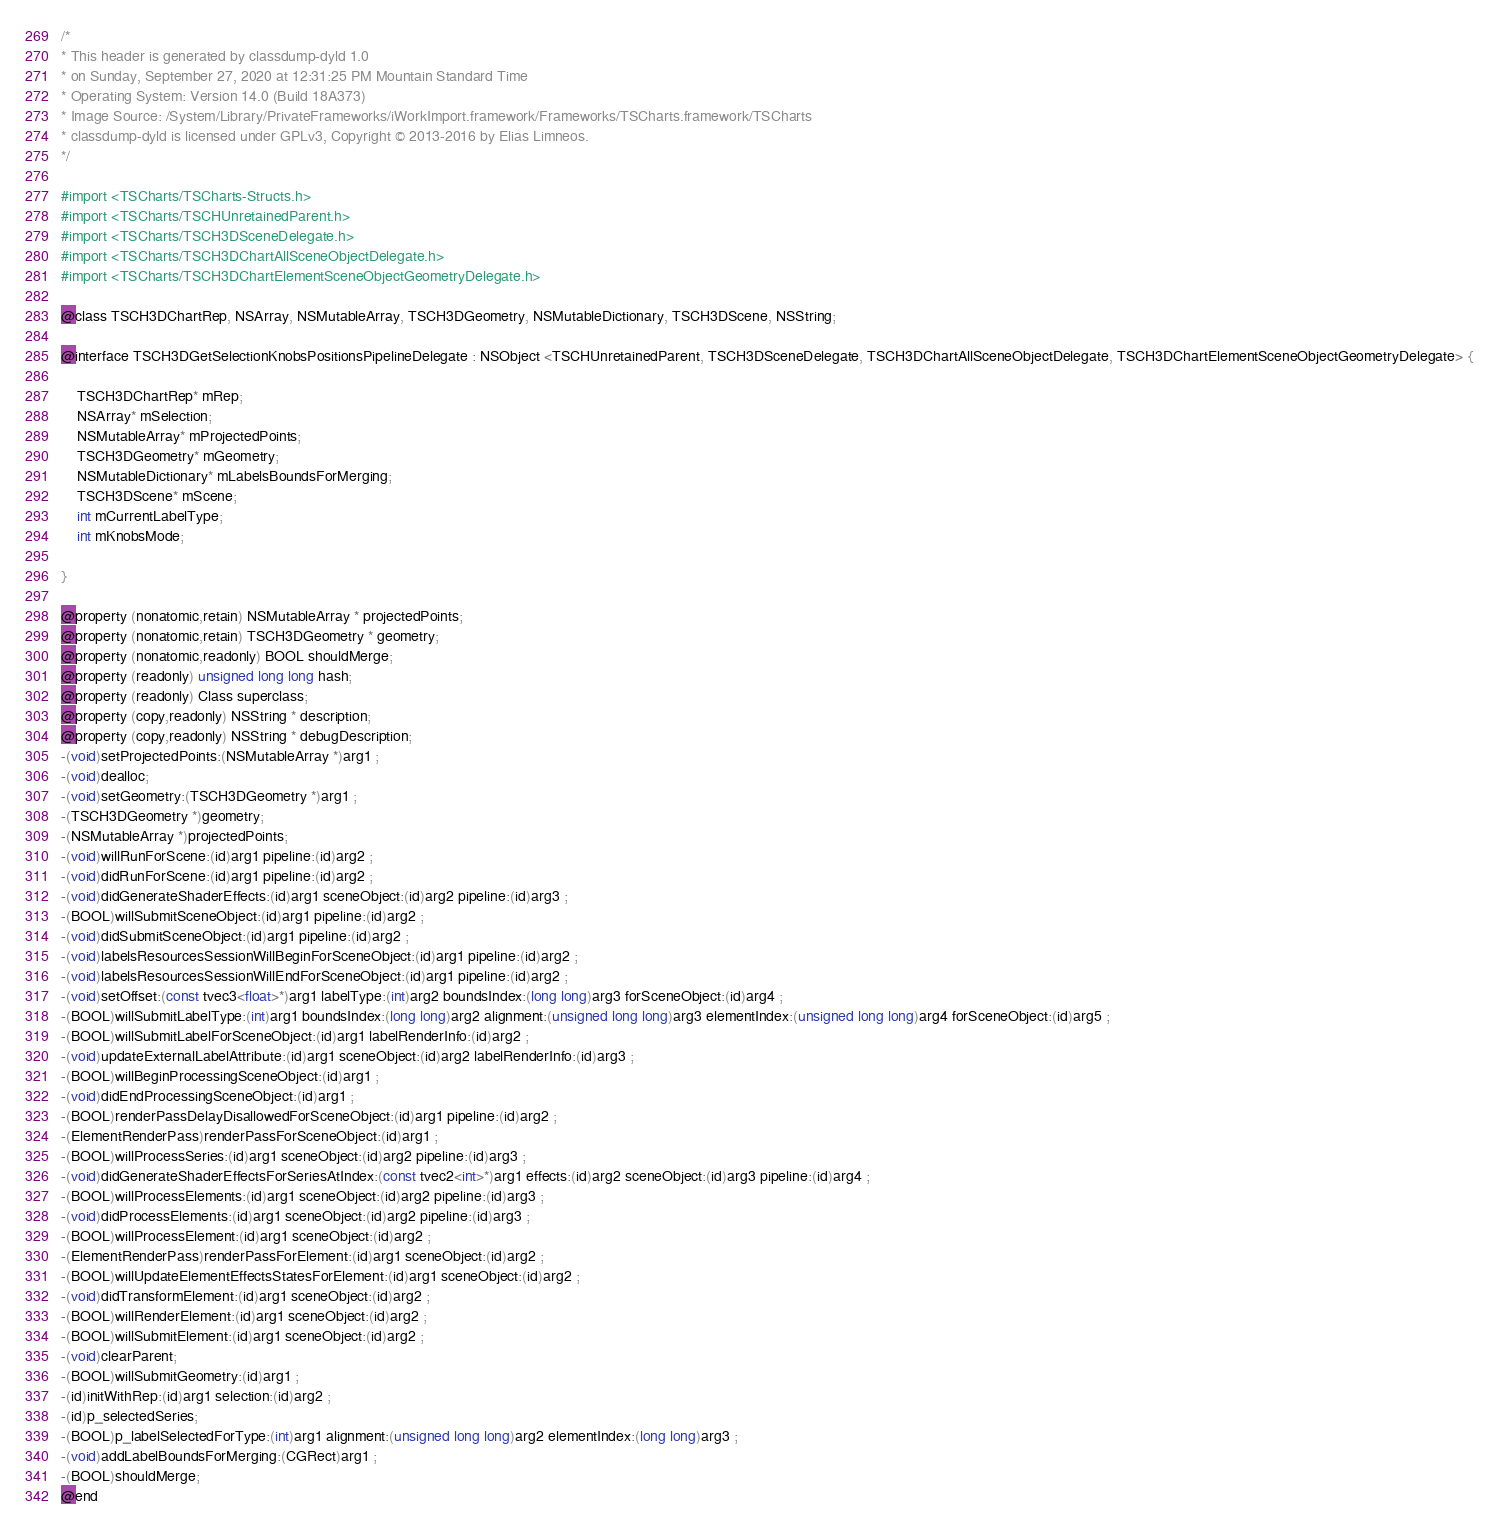<code> <loc_0><loc_0><loc_500><loc_500><_C_>/*
* This header is generated by classdump-dyld 1.0
* on Sunday, September 27, 2020 at 12:31:25 PM Mountain Standard Time
* Operating System: Version 14.0 (Build 18A373)
* Image Source: /System/Library/PrivateFrameworks/iWorkImport.framework/Frameworks/TSCharts.framework/TSCharts
* classdump-dyld is licensed under GPLv3, Copyright © 2013-2016 by Elias Limneos.
*/

#import <TSCharts/TSCharts-Structs.h>
#import <TSCharts/TSCHUnretainedParent.h>
#import <TSCharts/TSCH3DSceneDelegate.h>
#import <TSCharts/TSCH3DChartAllSceneObjectDelegate.h>
#import <TSCharts/TSCH3DChartElementSceneObjectGeometryDelegate.h>

@class TSCH3DChartRep, NSArray, NSMutableArray, TSCH3DGeometry, NSMutableDictionary, TSCH3DScene, NSString;

@interface TSCH3DGetSelectionKnobsPositionsPipelineDelegate : NSObject <TSCHUnretainedParent, TSCH3DSceneDelegate, TSCH3DChartAllSceneObjectDelegate, TSCH3DChartElementSceneObjectGeometryDelegate> {

	TSCH3DChartRep* mRep;
	NSArray* mSelection;
	NSMutableArray* mProjectedPoints;
	TSCH3DGeometry* mGeometry;
	NSMutableDictionary* mLabelsBoundsForMerging;
	TSCH3DScene* mScene;
	int mCurrentLabelType;
	int mKnobsMode;

}

@property (nonatomic,retain) NSMutableArray * projectedPoints; 
@property (nonatomic,retain) TSCH3DGeometry * geometry; 
@property (nonatomic,readonly) BOOL shouldMerge; 
@property (readonly) unsigned long long hash; 
@property (readonly) Class superclass; 
@property (copy,readonly) NSString * description; 
@property (copy,readonly) NSString * debugDescription; 
-(void)setProjectedPoints:(NSMutableArray *)arg1 ;
-(void)dealloc;
-(void)setGeometry:(TSCH3DGeometry *)arg1 ;
-(TSCH3DGeometry *)geometry;
-(NSMutableArray *)projectedPoints;
-(void)willRunForScene:(id)arg1 pipeline:(id)arg2 ;
-(void)didRunForScene:(id)arg1 pipeline:(id)arg2 ;
-(void)didGenerateShaderEffects:(id)arg1 sceneObject:(id)arg2 pipeline:(id)arg3 ;
-(BOOL)willSubmitSceneObject:(id)arg1 pipeline:(id)arg2 ;
-(void)didSubmitSceneObject:(id)arg1 pipeline:(id)arg2 ;
-(void)labelsResourcesSessionWillBeginForSceneObject:(id)arg1 pipeline:(id)arg2 ;
-(void)labelsResourcesSessionWillEndForSceneObject:(id)arg1 pipeline:(id)arg2 ;
-(void)setOffset:(const tvec3<float>*)arg1 labelType:(int)arg2 boundsIndex:(long long)arg3 forSceneObject:(id)arg4 ;
-(BOOL)willSubmitLabelType:(int)arg1 boundsIndex:(long long)arg2 alignment:(unsigned long long)arg3 elementIndex:(unsigned long long)arg4 forSceneObject:(id)arg5 ;
-(BOOL)willSubmitLabelForSceneObject:(id)arg1 labelRenderInfo:(id)arg2 ;
-(void)updateExternalLabelAttribute:(id)arg1 sceneObject:(id)arg2 labelRenderInfo:(id)arg3 ;
-(BOOL)willBeginProcessingSceneObject:(id)arg1 ;
-(void)didEndProcessingSceneObject:(id)arg1 ;
-(BOOL)renderPassDelayDisallowedForSceneObject:(id)arg1 pipeline:(id)arg2 ;
-(ElementRenderPass)renderPassForSceneObject:(id)arg1 ;
-(BOOL)willProcessSeries:(id)arg1 sceneObject:(id)arg2 pipeline:(id)arg3 ;
-(void)didGenerateShaderEffectsForSeriesAtIndex:(const tvec2<int>*)arg1 effects:(id)arg2 sceneObject:(id)arg3 pipeline:(id)arg4 ;
-(BOOL)willProcessElements:(id)arg1 sceneObject:(id)arg2 pipeline:(id)arg3 ;
-(void)didProcessElements:(id)arg1 sceneObject:(id)arg2 pipeline:(id)arg3 ;
-(BOOL)willProcessElement:(id)arg1 sceneObject:(id)arg2 ;
-(ElementRenderPass)renderPassForElement:(id)arg1 sceneObject:(id)arg2 ;
-(BOOL)willUpdateElementEffectsStatesForElement:(id)arg1 sceneObject:(id)arg2 ;
-(void)didTransformElement:(id)arg1 sceneObject:(id)arg2 ;
-(BOOL)willRenderElement:(id)arg1 sceneObject:(id)arg2 ;
-(BOOL)willSubmitElement:(id)arg1 sceneObject:(id)arg2 ;
-(void)clearParent;
-(BOOL)willSubmitGeometry:(id)arg1 ;
-(id)initWithRep:(id)arg1 selection:(id)arg2 ;
-(id)p_selectedSeries;
-(BOOL)p_labelSelectedForType:(int)arg1 alignment:(unsigned long long)arg2 elementIndex:(long long)arg3 ;
-(void)addLabelBoundsForMerging:(CGRect)arg1 ;
-(BOOL)shouldMerge;
@end

</code> 